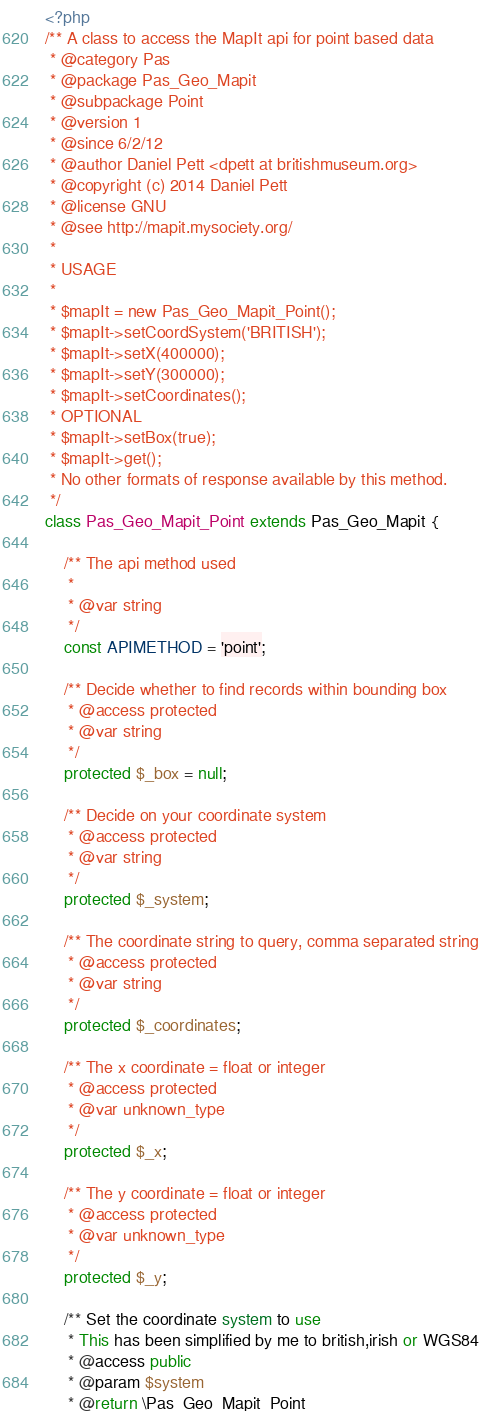Convert code to text. <code><loc_0><loc_0><loc_500><loc_500><_PHP_><?php
/** A class to access the MapIt api for point based data
 * @category Pas
 * @package Pas_Geo_Mapit
 * @subpackage Point
 * @version 1
 * @since 6/2/12
 * @author Daniel Pett <dpett at britishmuseum.org>
 * @copyright (c) 2014 Daniel Pett
 * @license GNU
 * @see http://mapit.mysociety.org/
 *
 * USAGE
 *
 * $mapIt = new Pas_Geo_Mapit_Point();
 * $mapIt->setCoordSystem('BRITISH');
 * $mapIt->setX(400000);
 * $mapIt->setY(300000);
 * $mapIt->setCoordinates();
 * OPTIONAL
 * $mapIt->setBox(true);
 * $mapIt->get();
 * No other formats of response available by this method.
 */
class Pas_Geo_Mapit_Point extends Pas_Geo_Mapit {

    /** The api method used
     *
     * @var string
     */
    const APIMETHOD = 'point';

    /** Decide whether to find records within bounding box
     * @access protected
     * @var string
     */
    protected $_box = null;

    /** Decide on your coordinate system
     * @access protected
     * @var string
     */
    protected $_system;

    /** The coordinate string to query, comma separated string
     * @access protected
     * @var string
     */
    protected $_coordinates;

    /** The x coordinate = float or integer
     * @access protected
     * @var unknown_type
     */
    protected $_x;

    /** The y coordinate = float or integer
     * @access protected
     * @var unknown_type
     */
    protected $_y;

    /** Set the coordinate system to use
     * This has been simplified by me to british,irish or WGS84
     * @access public
     * @param $system
     * @return \Pas_Geo_Mapit_Point</code> 